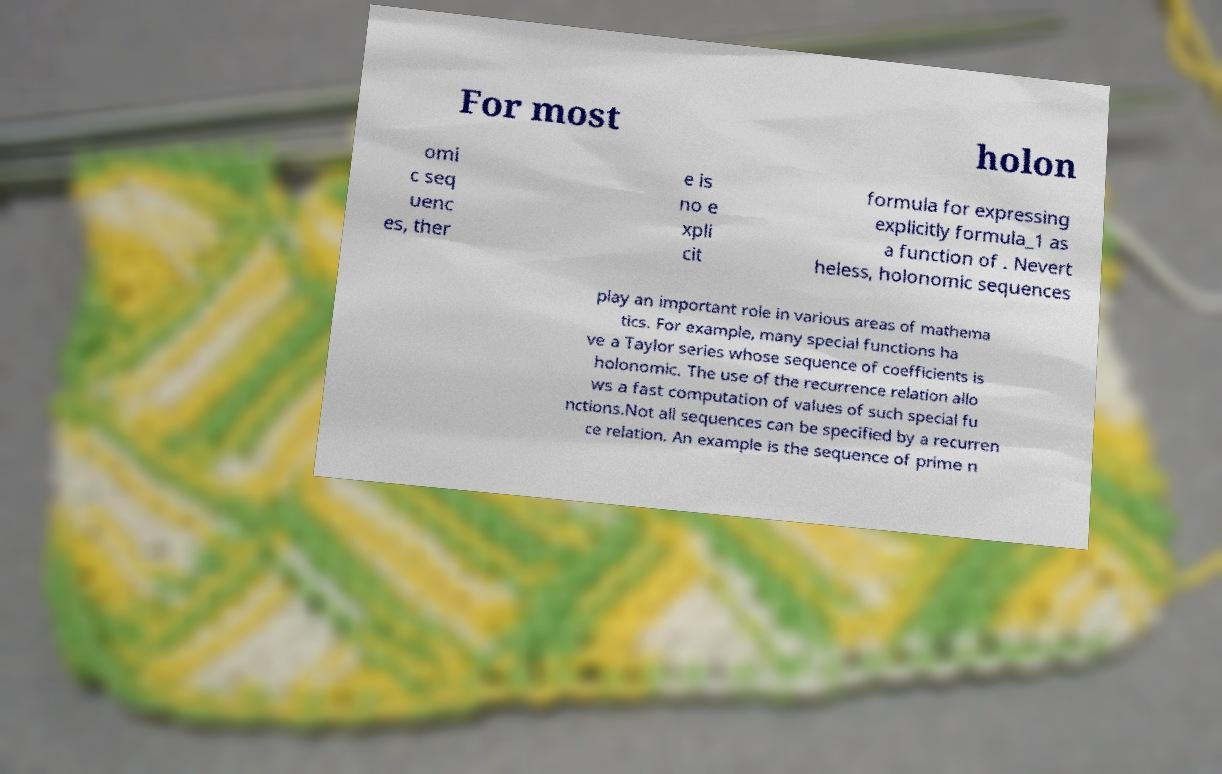For documentation purposes, I need the text within this image transcribed. Could you provide that? For most holon omi c seq uenc es, ther e is no e xpli cit formula for expressing explicitly formula_1 as a function of . Nevert heless, holonomic sequences play an important role in various areas of mathema tics. For example, many special functions ha ve a Taylor series whose sequence of coefficients is holonomic. The use of the recurrence relation allo ws a fast computation of values of such special fu nctions.Not all sequences can be specified by a recurren ce relation. An example is the sequence of prime n 